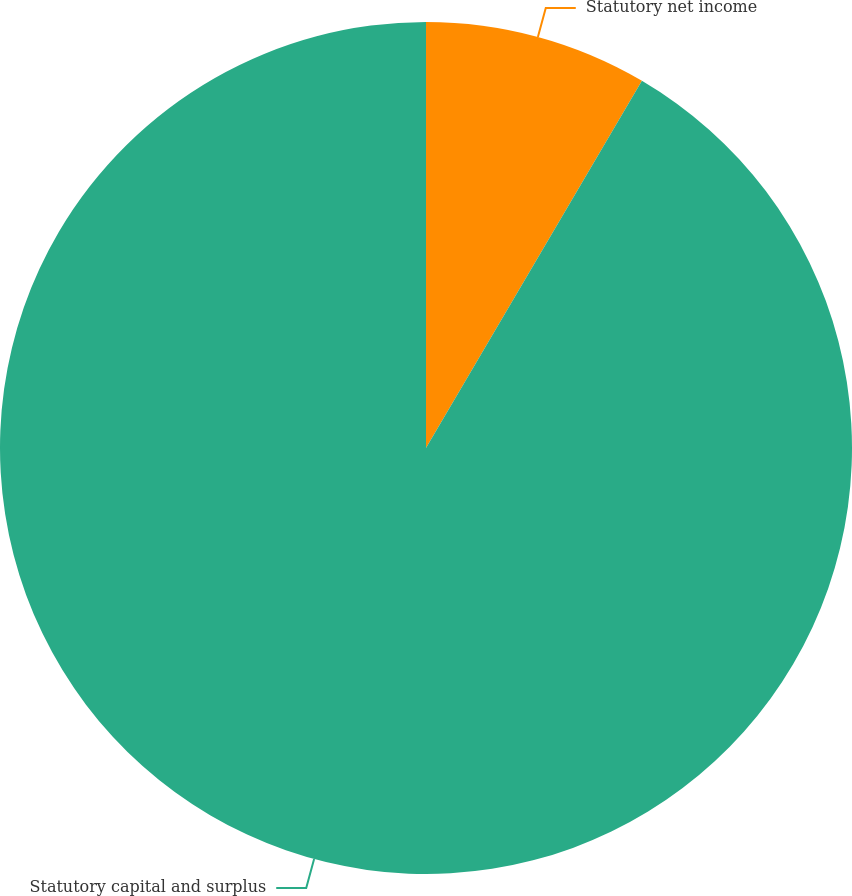Convert chart. <chart><loc_0><loc_0><loc_500><loc_500><pie_chart><fcel>Statutory net income<fcel>Statutory capital and surplus<nl><fcel>8.46%<fcel>91.54%<nl></chart> 